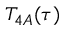<formula> <loc_0><loc_0><loc_500><loc_500>T _ { 4 A } ( \tau )</formula> 